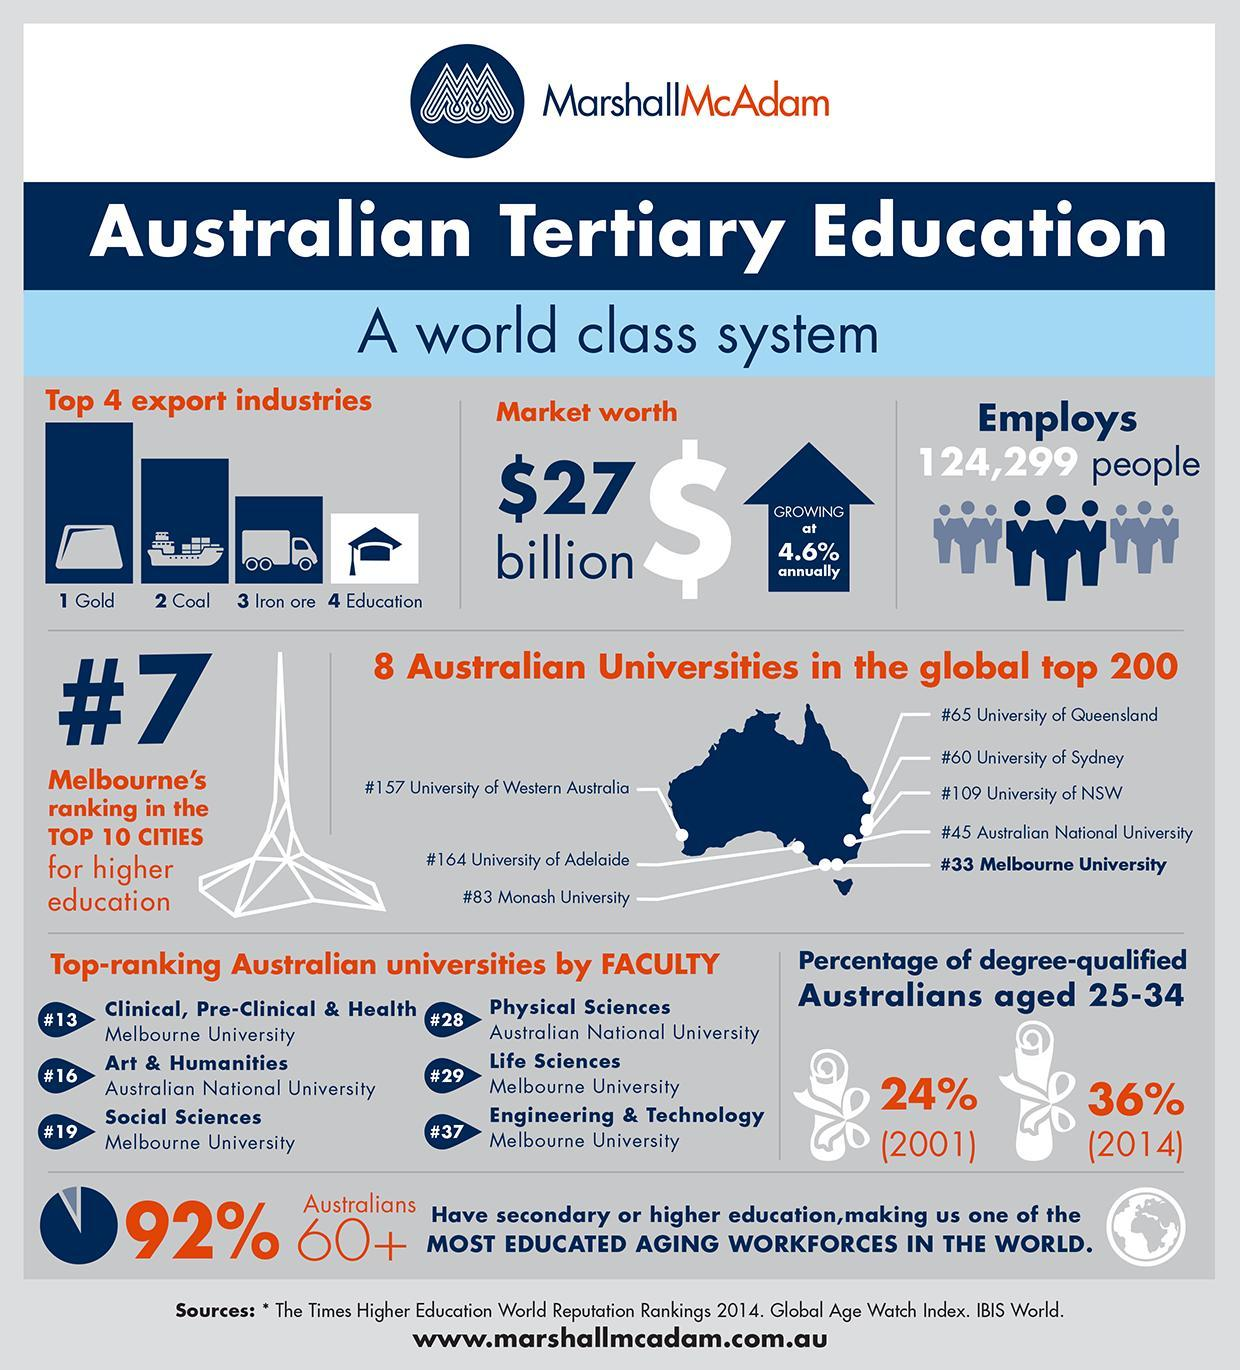What is the increase in the percentile number of Australians who gained degrees in 2014 in comparison to 2001?
Answer the question with a short phrase. 12% 